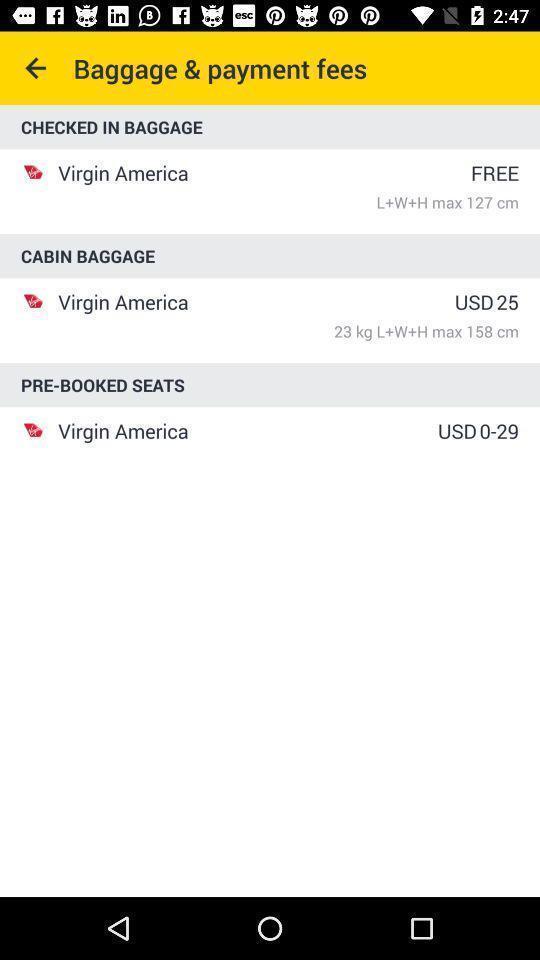Provide a description of this screenshot. Payments page of an airlines app. 